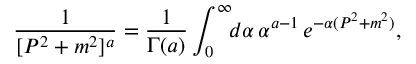Convert formula to latex. <formula><loc_0><loc_0><loc_500><loc_500>\frac { 1 } { [ P ^ { 2 } + m ^ { 2 } ] ^ { a } } = \frac { 1 } { \Gamma ( a ) } \int _ { 0 } ^ { \infty } \, d \alpha \, \alpha ^ { a - 1 } \, e ^ { - \alpha ( P ^ { 2 } + m ^ { 2 } ) } ,</formula> 